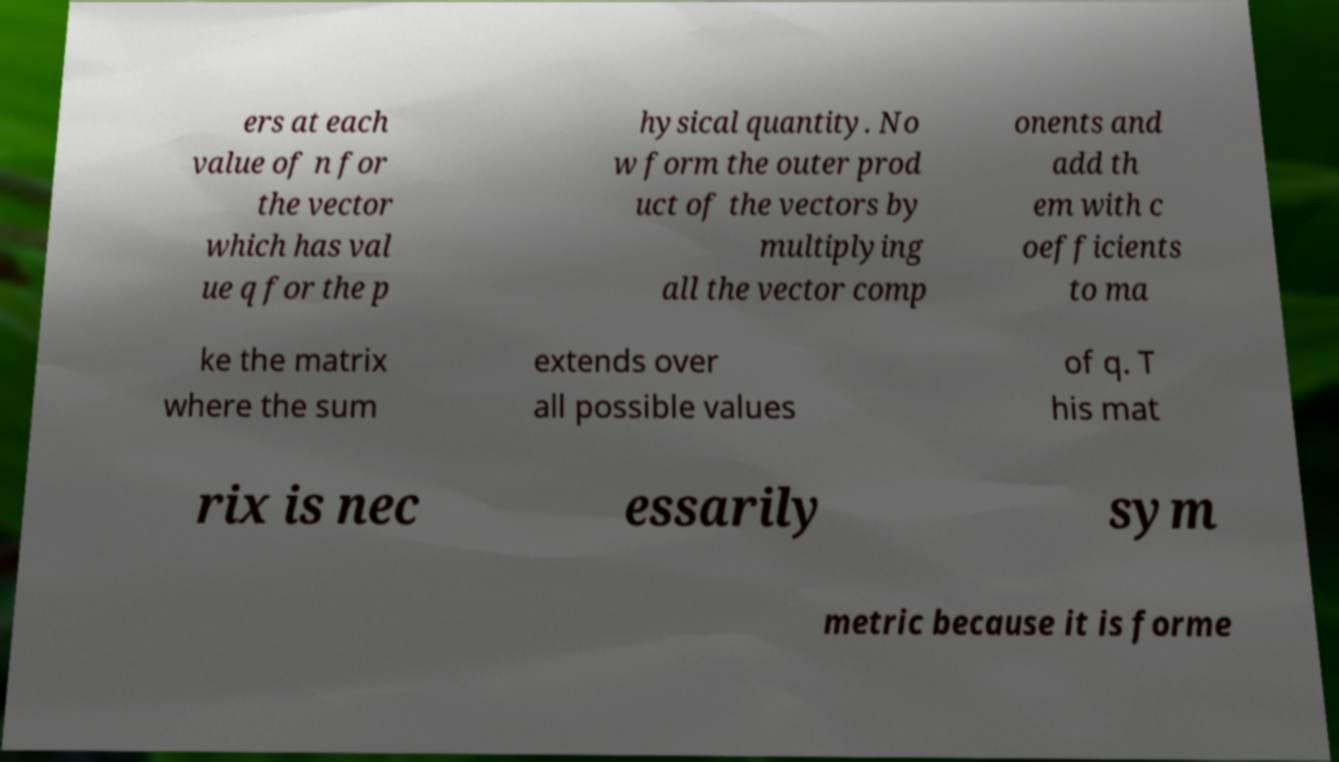Can you accurately transcribe the text from the provided image for me? ers at each value of n for the vector which has val ue q for the p hysical quantity. No w form the outer prod uct of the vectors by multiplying all the vector comp onents and add th em with c oefficients to ma ke the matrix where the sum extends over all possible values of q. T his mat rix is nec essarily sym metric because it is forme 